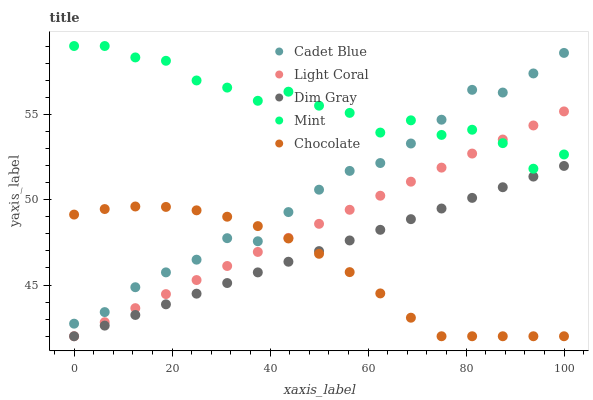Does Chocolate have the minimum area under the curve?
Answer yes or no. Yes. Does Mint have the maximum area under the curve?
Answer yes or no. Yes. Does Dim Gray have the minimum area under the curve?
Answer yes or no. No. Does Dim Gray have the maximum area under the curve?
Answer yes or no. No. Is Light Coral the smoothest?
Answer yes or no. Yes. Is Mint the roughest?
Answer yes or no. Yes. Is Dim Gray the smoothest?
Answer yes or no. No. Is Dim Gray the roughest?
Answer yes or no. No. Does Light Coral have the lowest value?
Answer yes or no. Yes. Does Cadet Blue have the lowest value?
Answer yes or no. No. Does Mint have the highest value?
Answer yes or no. Yes. Does Dim Gray have the highest value?
Answer yes or no. No. Is Dim Gray less than Mint?
Answer yes or no. Yes. Is Cadet Blue greater than Light Coral?
Answer yes or no. Yes. Does Cadet Blue intersect Mint?
Answer yes or no. Yes. Is Cadet Blue less than Mint?
Answer yes or no. No. Is Cadet Blue greater than Mint?
Answer yes or no. No. Does Dim Gray intersect Mint?
Answer yes or no. No. 